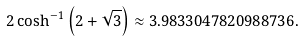<formula> <loc_0><loc_0><loc_500><loc_500>2 \cosh ^ { - 1 } \left ( 2 + { \sqrt { 3 } } \right ) \approx 3 . 9 8 3 3 0 4 7 8 2 0 9 8 8 7 3 6 .</formula> 